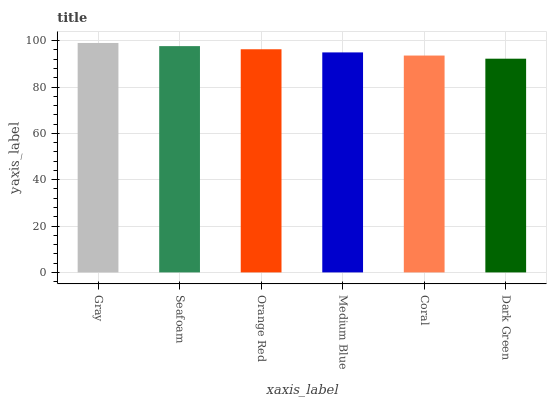Is Dark Green the minimum?
Answer yes or no. Yes. Is Gray the maximum?
Answer yes or no. Yes. Is Seafoam the minimum?
Answer yes or no. No. Is Seafoam the maximum?
Answer yes or no. No. Is Gray greater than Seafoam?
Answer yes or no. Yes. Is Seafoam less than Gray?
Answer yes or no. Yes. Is Seafoam greater than Gray?
Answer yes or no. No. Is Gray less than Seafoam?
Answer yes or no. No. Is Orange Red the high median?
Answer yes or no. Yes. Is Medium Blue the low median?
Answer yes or no. Yes. Is Coral the high median?
Answer yes or no. No. Is Dark Green the low median?
Answer yes or no. No. 